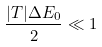Convert formula to latex. <formula><loc_0><loc_0><loc_500><loc_500>\frac { | T | \Delta E _ { 0 } } { 2 } \ll 1</formula> 